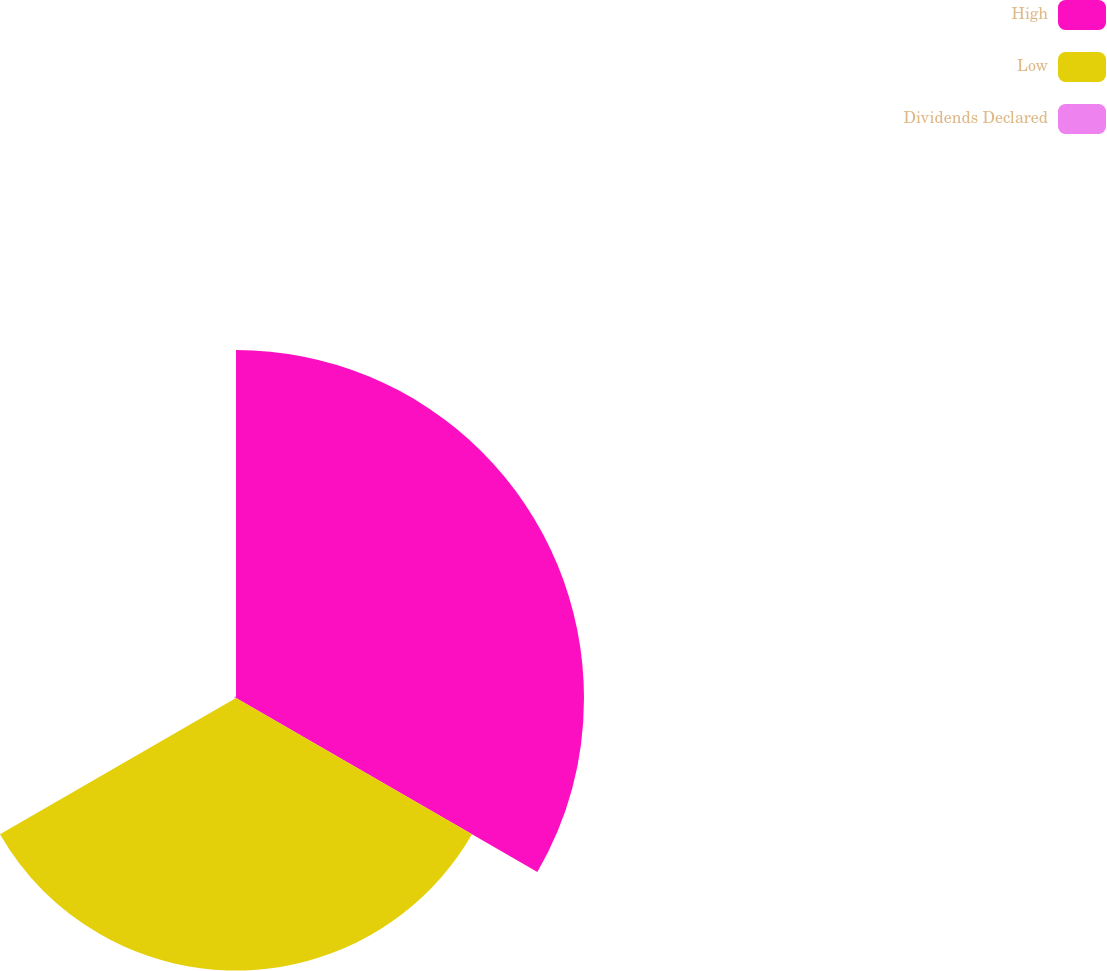Convert chart. <chart><loc_0><loc_0><loc_500><loc_500><pie_chart><fcel>High<fcel>Low<fcel>Dividends Declared<nl><fcel>55.93%<fcel>43.8%<fcel>0.27%<nl></chart> 